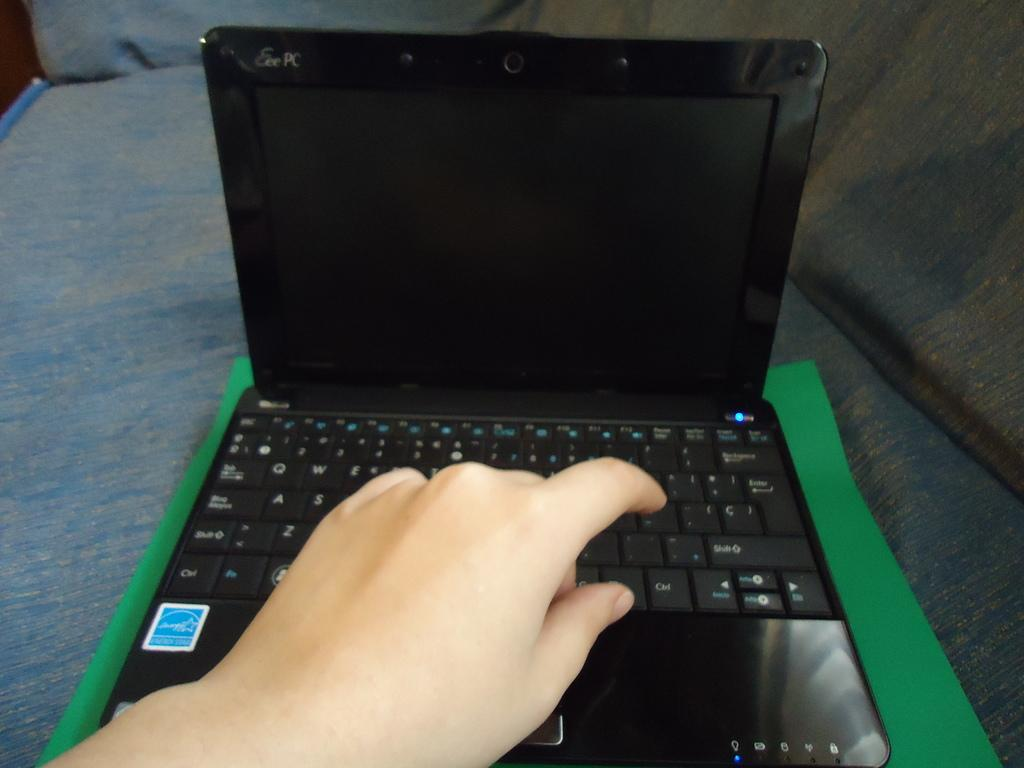Provide a one-sentence caption for the provided image. Someone is typing on a laptop made by Eee PC. 